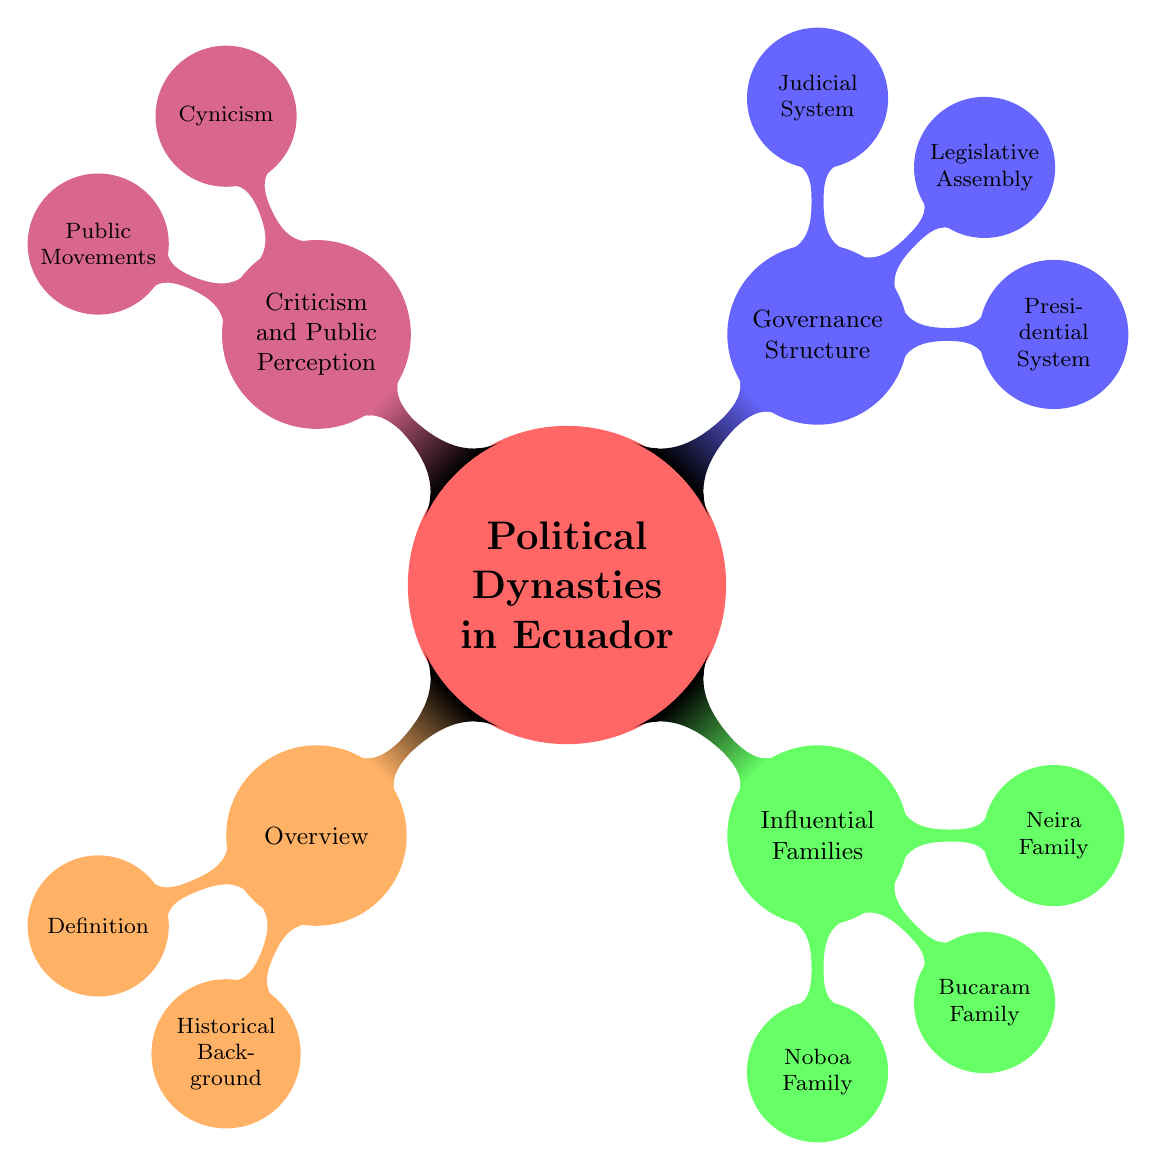What is the definition of political dynasties in Ecuador? The definition can be found in the 'Overview' node under 'Political Dynasties in Ecuador'. It states that political dynasties are "Families holding political power across generations."
Answer: Families holding political power across generations How many influential families are mentioned? By examining the 'Influential Families' node, we can count three families listed: Noboa Family, Bucaram Family, and Neira Family.
Answer: Three Which family is associated with corruption allegations? The 'Bucaram Family' node lists "Corruption allegations" under the scandals associated with them.
Answer: Bucaram Family What is the main criticism found in the diagram? Under the 'Criticism and Public Perception' section, the word "Cynicism" appears, indicating that it is a key criticism regarding political dynasties.
Answer: Cynicism What role does the Judicial System play in relation to political families? Looking at the 'Judicial System' node, it states that while it is "formally independent," it is "often influenced by political families," showing the impact of these families on the judiciary.
Answer: Often influenced by political families How are the members of the Legislative Assembly chosen? The 'Legislative Assembly' node indicates that members are "Elected representatives," specifying the method of selection.
Answer: Elected representatives What type of governance structure is primarily discussed? The diagram outlines a 'Presidential System' as part of the governance structure for Ecuador's political dynasties.
Answer: Presidential System Which influential family is connected to the banana industry? Referring to the 'Noboa Family' node, it mentions "Banana industry" as one of their business interests.
Answer: Noboa Family 